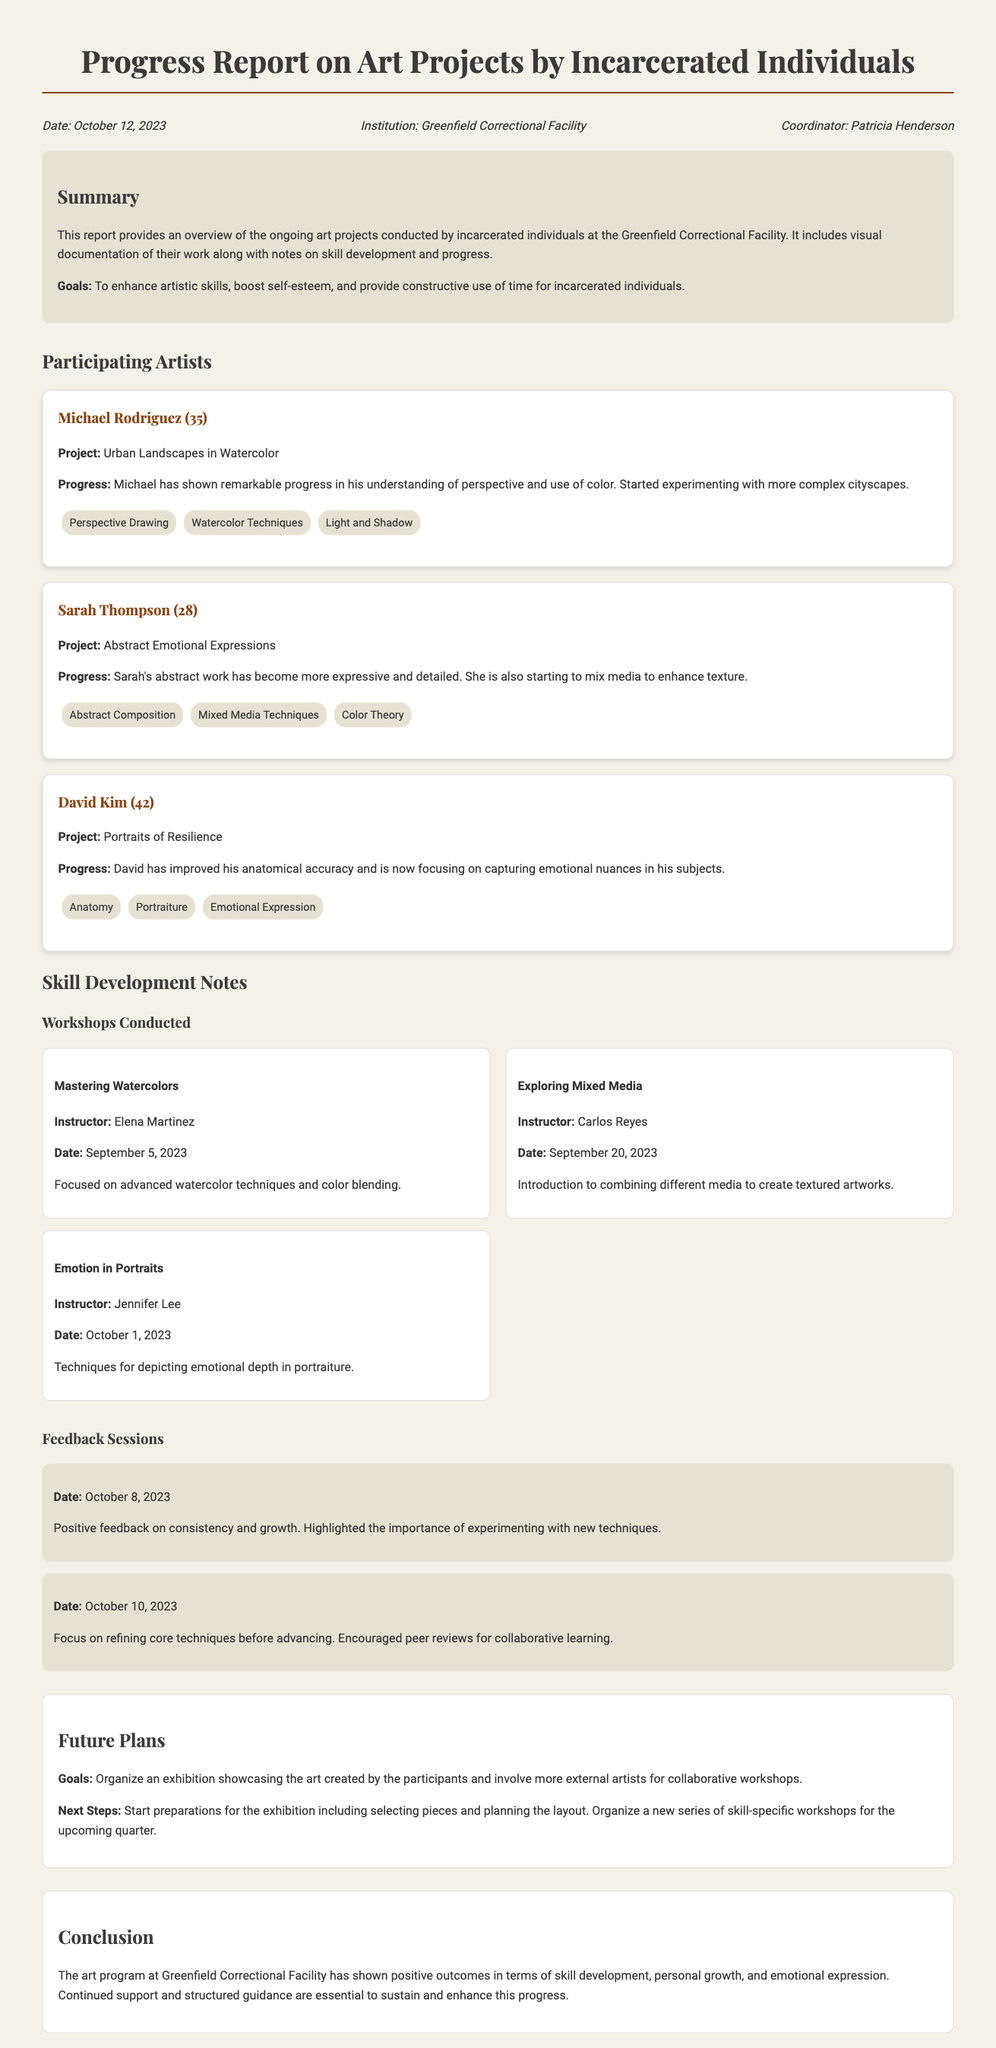What is the date of the report? The date of the report is provided in the header information at the top of the document.
Answer: October 12, 2023 Who is the coordinator of the art program? The coordinator's name is mentioned in the header section of the report.
Answer: Patricia Henderson What project is Michael Rodriguez working on? The project title for Michael Rodriguez is described in his artist card section.
Answer: Urban Landscapes in Watercolor How many workshops were conducted according to the report? The number of workshops can be counted from the workshops section in the document.
Answer: 3 What skill is Sarah Thompson developing? The skills Sarah is focusing on are listed under her artist card.
Answer: Mixed Media Techniques Which workshop was held on October 1, 2023? The date and workshop title are detailed in the workshops section.
Answer: Emotion in Portraits What is the goal for future plans regarding exhibitions? The goals for future plans are specified in the future plans section of the document.
Answer: Showcase the art created by the participants What type of art does David Kim focus on? David Kim's focus area is mentioned in his artist card section under the project title.
Answer: Portraits of Resilience What is highlighted in the feedback session from October 10, 2023? The key points from the feedback session dates can be found in that section of the report.
Answer: Refine core techniques before advancing 